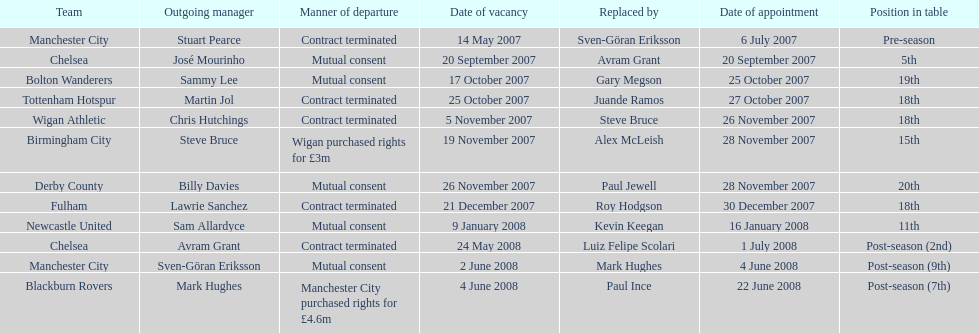Which team was the sole one to achieve a 5th place ranking? Chelsea. 